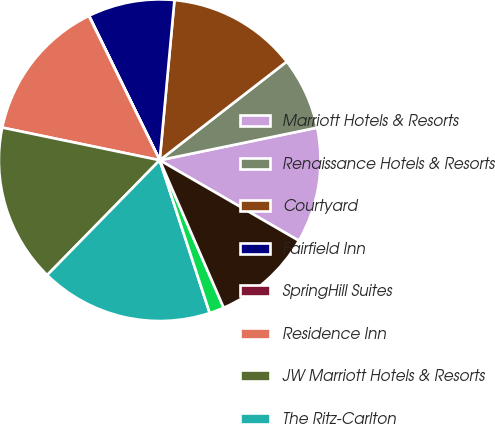Convert chart. <chart><loc_0><loc_0><loc_500><loc_500><pie_chart><fcel>Marriott Hotels & Resorts<fcel>Renaissance Hotels & Resorts<fcel>Courtyard<fcel>Fairfield Inn<fcel>SpringHill Suites<fcel>Residence Inn<fcel>JW Marriott Hotels & Resorts<fcel>The Ritz-Carlton<fcel>The Ritz-Carlton-Residential<fcel>Marriott Vacation Club<nl><fcel>11.59%<fcel>7.26%<fcel>13.03%<fcel>8.7%<fcel>0.03%<fcel>14.48%<fcel>15.92%<fcel>17.37%<fcel>1.48%<fcel>10.14%<nl></chart> 